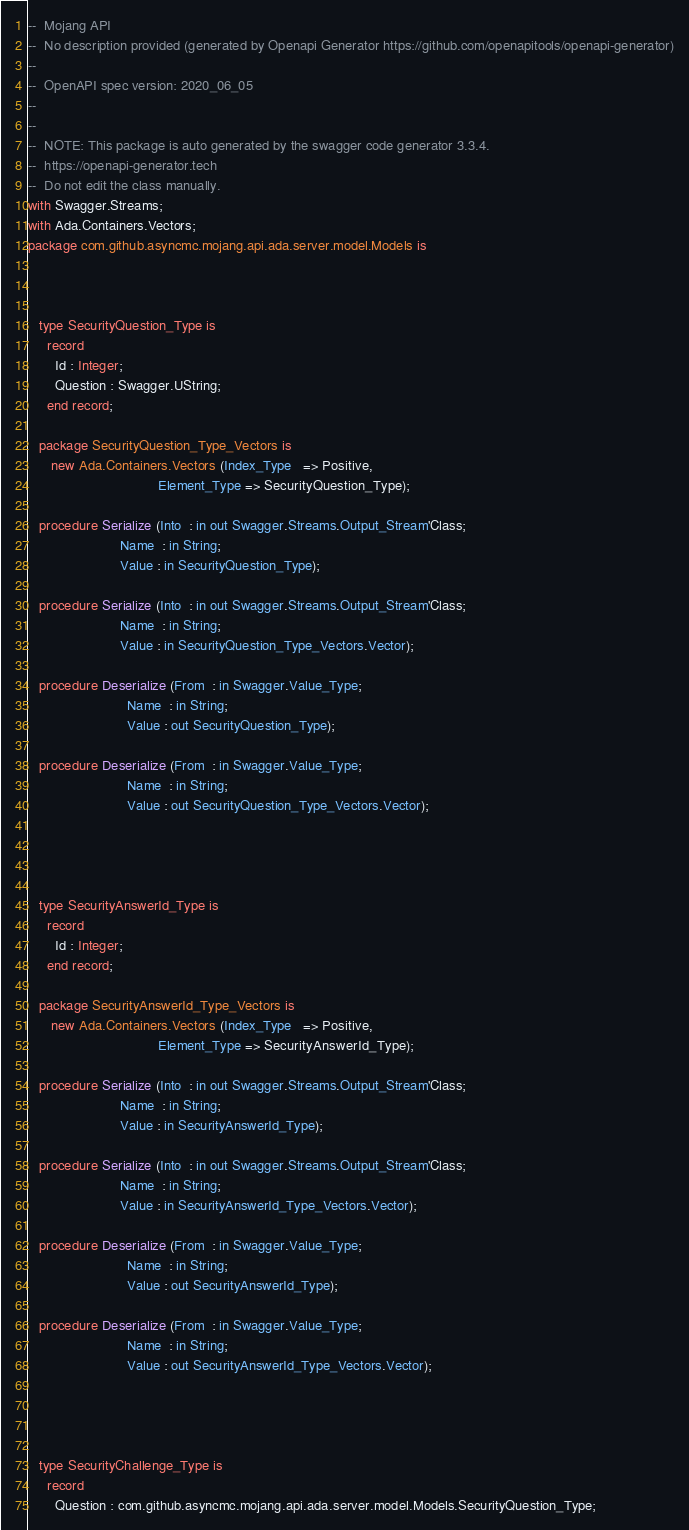Convert code to text. <code><loc_0><loc_0><loc_500><loc_500><_Ada_>--  Mojang API
--  No description provided (generated by Openapi Generator https://github.com/openapitools/openapi-generator)
--
--  OpenAPI spec version: 2020_06_05
--  
--
--  NOTE: This package is auto generated by the swagger code generator 3.3.4.
--  https://openapi-generator.tech
--  Do not edit the class manually.
with Swagger.Streams;
with Ada.Containers.Vectors;
package com.github.asyncmc.mojang.api.ada.server.model.Models is



   type SecurityQuestion_Type is
     record
       Id : Integer;
       Question : Swagger.UString;
     end record;

   package SecurityQuestion_Type_Vectors is
      new Ada.Containers.Vectors (Index_Type   => Positive,
                                  Element_Type => SecurityQuestion_Type);

   procedure Serialize (Into  : in out Swagger.Streams.Output_Stream'Class;
                        Name  : in String;
                        Value : in SecurityQuestion_Type);

   procedure Serialize (Into  : in out Swagger.Streams.Output_Stream'Class;
                        Name  : in String;
                        Value : in SecurityQuestion_Type_Vectors.Vector);

   procedure Deserialize (From  : in Swagger.Value_Type;
                          Name  : in String;
                          Value : out SecurityQuestion_Type);

   procedure Deserialize (From  : in Swagger.Value_Type;
                          Name  : in String;
                          Value : out SecurityQuestion_Type_Vectors.Vector);




   type SecurityAnswerId_Type is
     record
       Id : Integer;
     end record;

   package SecurityAnswerId_Type_Vectors is
      new Ada.Containers.Vectors (Index_Type   => Positive,
                                  Element_Type => SecurityAnswerId_Type);

   procedure Serialize (Into  : in out Swagger.Streams.Output_Stream'Class;
                        Name  : in String;
                        Value : in SecurityAnswerId_Type);

   procedure Serialize (Into  : in out Swagger.Streams.Output_Stream'Class;
                        Name  : in String;
                        Value : in SecurityAnswerId_Type_Vectors.Vector);

   procedure Deserialize (From  : in Swagger.Value_Type;
                          Name  : in String;
                          Value : out SecurityAnswerId_Type);

   procedure Deserialize (From  : in Swagger.Value_Type;
                          Name  : in String;
                          Value : out SecurityAnswerId_Type_Vectors.Vector);




   type SecurityChallenge_Type is
     record
       Question : com.github.asyncmc.mojang.api.ada.server.model.Models.SecurityQuestion_Type;</code> 